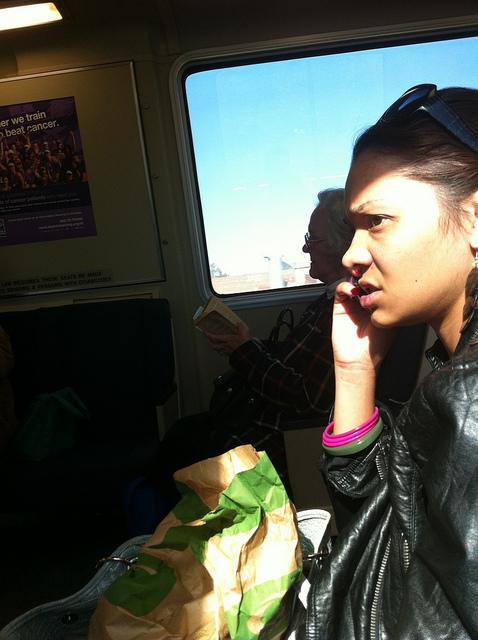What color hair does the woman on the phone have?
Be succinct. Brown. Is this woman happy?
Give a very brief answer. No. Is she in a bar?
Be succinct. No. 